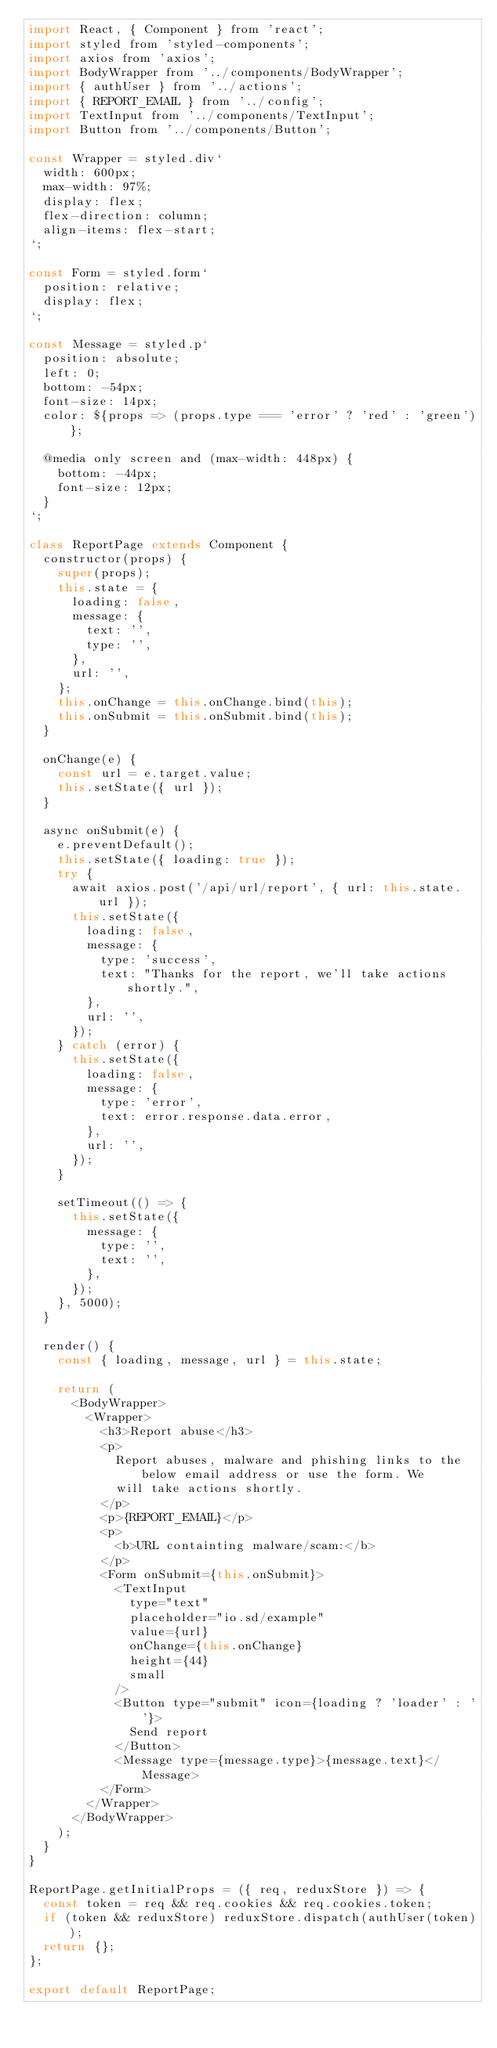<code> <loc_0><loc_0><loc_500><loc_500><_JavaScript_>import React, { Component } from 'react';
import styled from 'styled-components';
import axios from 'axios';
import BodyWrapper from '../components/BodyWrapper';
import { authUser } from '../actions';
import { REPORT_EMAIL } from '../config';
import TextInput from '../components/TextInput';
import Button from '../components/Button';

const Wrapper = styled.div`
  width: 600px;
  max-width: 97%;
  display: flex;
  flex-direction: column;
  align-items: flex-start;
`;

const Form = styled.form`
  position: relative;
  display: flex;
`;

const Message = styled.p`
  position: absolute;
  left: 0;
  bottom: -54px;
  font-size: 14px;
  color: ${props => (props.type === 'error' ? 'red' : 'green')};

  @media only screen and (max-width: 448px) {
    bottom: -44px;
    font-size: 12px;
  }
`;

class ReportPage extends Component {
  constructor(props) {
    super(props);
    this.state = {
      loading: false,
      message: {
        text: '',
        type: '',
      },
      url: '',
    };
    this.onChange = this.onChange.bind(this);
    this.onSubmit = this.onSubmit.bind(this);
  }

  onChange(e) {
    const url = e.target.value;
    this.setState({ url });
  }

  async onSubmit(e) {
    e.preventDefault();
    this.setState({ loading: true });
    try {
      await axios.post('/api/url/report', { url: this.state.url });
      this.setState({
        loading: false,
        message: {
          type: 'success',
          text: "Thanks for the report, we'll take actions shortly.",
        },
        url: '',
      });
    } catch (error) {
      this.setState({
        loading: false,
        message: {
          type: 'error',
          text: error.response.data.error,
        },
        url: '',
      });
    }

    setTimeout(() => {
      this.setState({
        message: {
          type: '',
          text: '',
        },
      });
    }, 5000);
  }

  render() {
    const { loading, message, url } = this.state;

    return (
      <BodyWrapper>
        <Wrapper>
          <h3>Report abuse</h3>
          <p>
            Report abuses, malware and phishing links to the below email address or use the form. We
            will take actions shortly.
          </p>
          <p>{REPORT_EMAIL}</p>
          <p>
            <b>URL containting malware/scam:</b>
          </p>
          <Form onSubmit={this.onSubmit}>
            <TextInput
              type="text"
              placeholder="io.sd/example"
              value={url}
              onChange={this.onChange}
              height={44}
              small
            />
            <Button type="submit" icon={loading ? 'loader' : ''}>
              Send report
            </Button>
            <Message type={message.type}>{message.text}</Message>
          </Form>
        </Wrapper>
      </BodyWrapper>
    );
  }
}

ReportPage.getInitialProps = ({ req, reduxStore }) => {
  const token = req && req.cookies && req.cookies.token;
  if (token && reduxStore) reduxStore.dispatch(authUser(token));
  return {};
};

export default ReportPage;
</code> 